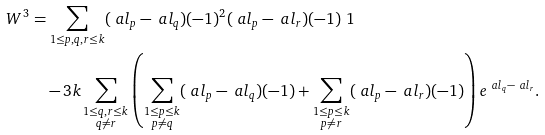<formula> <loc_0><loc_0><loc_500><loc_500>W ^ { 3 } & = \sum _ { 1 \leq p , q , r \leq k } ( \ a l _ { p } - \ a l _ { q } ) ( - 1 ) ^ { 2 } ( \ a l _ { p } - \ a l _ { r } ) ( - 1 ) \ 1 \\ & \quad - 3 k \sum _ { \substack { 1 \leq q , r \leq k \\ q \ne r } } \left ( \sum _ { \substack { 1 \leq p \leq k \\ p \ne q } } ( \ a l _ { p } - \ a l _ { q } ) ( - 1 ) + \sum _ { \substack { 1 \leq p \leq k \\ p \ne r } } ( \ a l _ { p } - \ a l _ { r } ) ( - 1 ) \right ) e ^ { \ a l _ { q } - \ a l _ { r } } .</formula> 